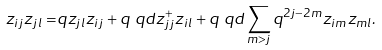Convert formula to latex. <formula><loc_0><loc_0><loc_500><loc_500>z _ { i j } z _ { j l } = & q z _ { j l } z _ { i j } + q \ q d z _ { j j } ^ { + } z _ { i l } + q \ q d \sum _ { m > j } q ^ { 2 j - 2 m } z _ { i m } z _ { m l } .</formula> 